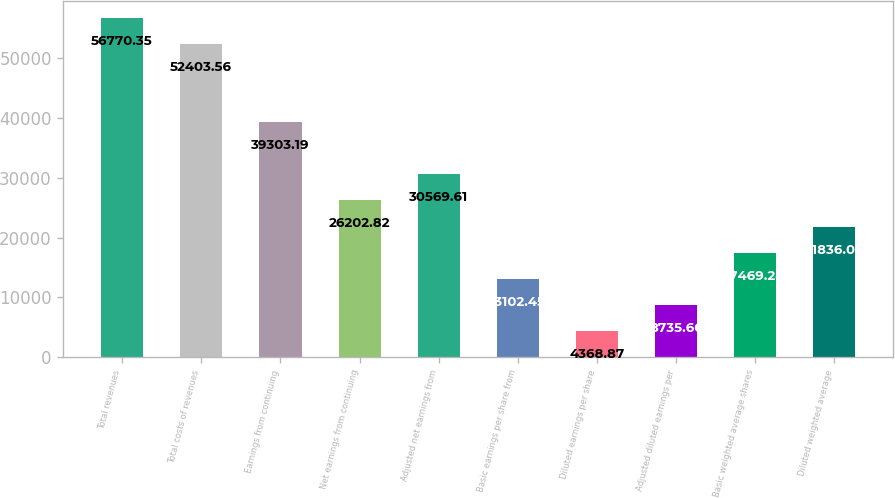<chart> <loc_0><loc_0><loc_500><loc_500><bar_chart><fcel>Total revenues<fcel>Total costs of revenues<fcel>Earnings from continuing<fcel>Net earnings from continuing<fcel>Adjusted net earnings from<fcel>Basic earnings per share from<fcel>Diluted earnings per share<fcel>Adjusted diluted earnings per<fcel>Basic weighted average shares<fcel>Diluted weighted average<nl><fcel>56770.3<fcel>52403.6<fcel>39303.2<fcel>26202.8<fcel>30569.6<fcel>13102.5<fcel>4368.87<fcel>8735.66<fcel>17469.2<fcel>21836<nl></chart> 